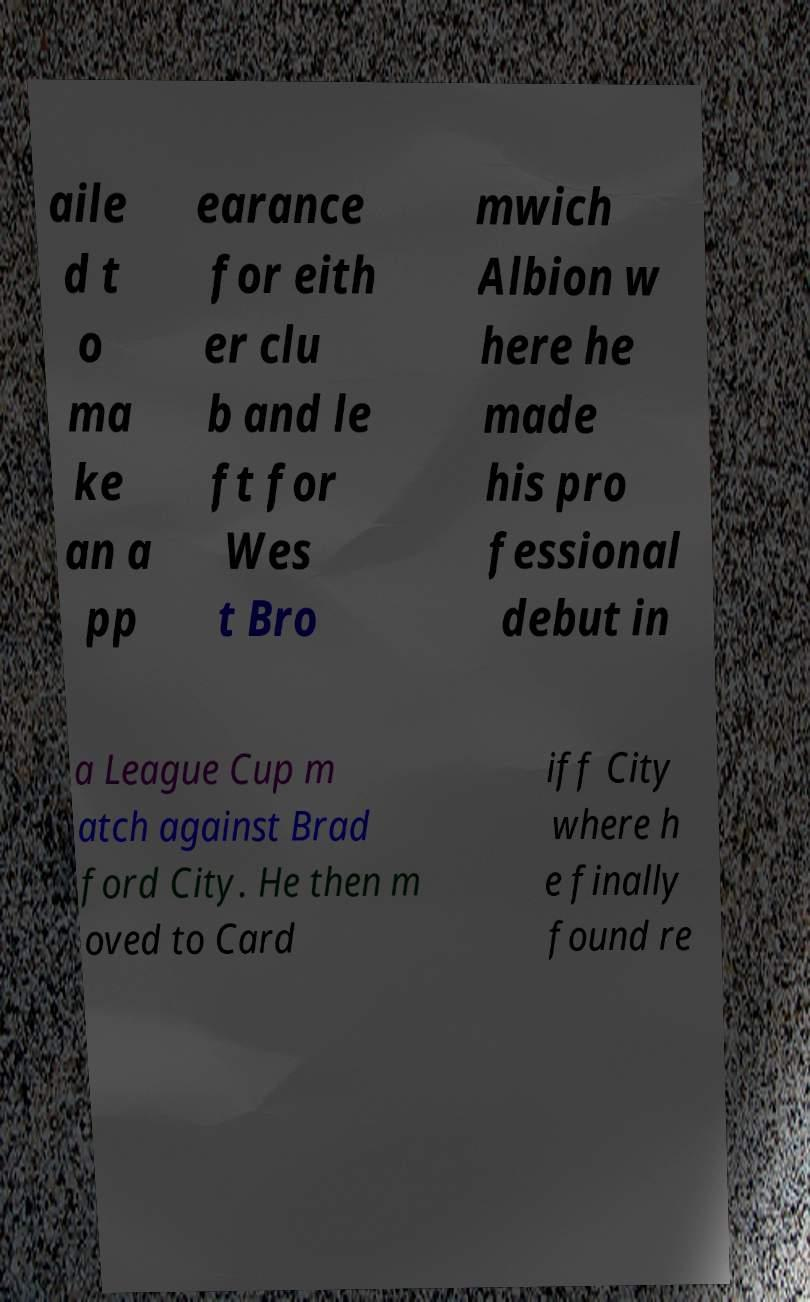I need the written content from this picture converted into text. Can you do that? aile d t o ma ke an a pp earance for eith er clu b and le ft for Wes t Bro mwich Albion w here he made his pro fessional debut in a League Cup m atch against Brad ford City. He then m oved to Card iff City where h e finally found re 